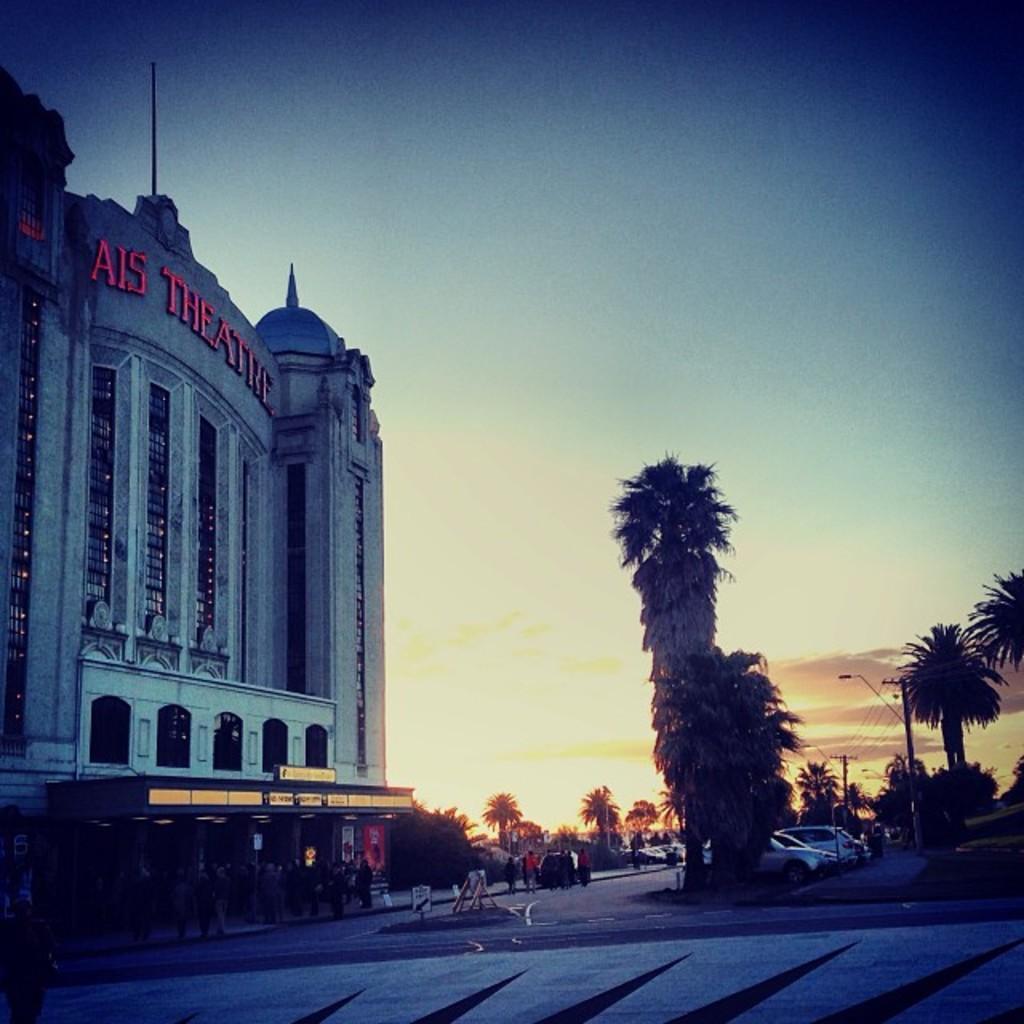Could you give a brief overview of what you see in this image? This is an outside view. At the bottom there is a road and I can see many trees and few vehicles. On the left side there is a building. At the top of the image I can see the sky. 